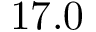<formula> <loc_0><loc_0><loc_500><loc_500>1 7 . 0</formula> 